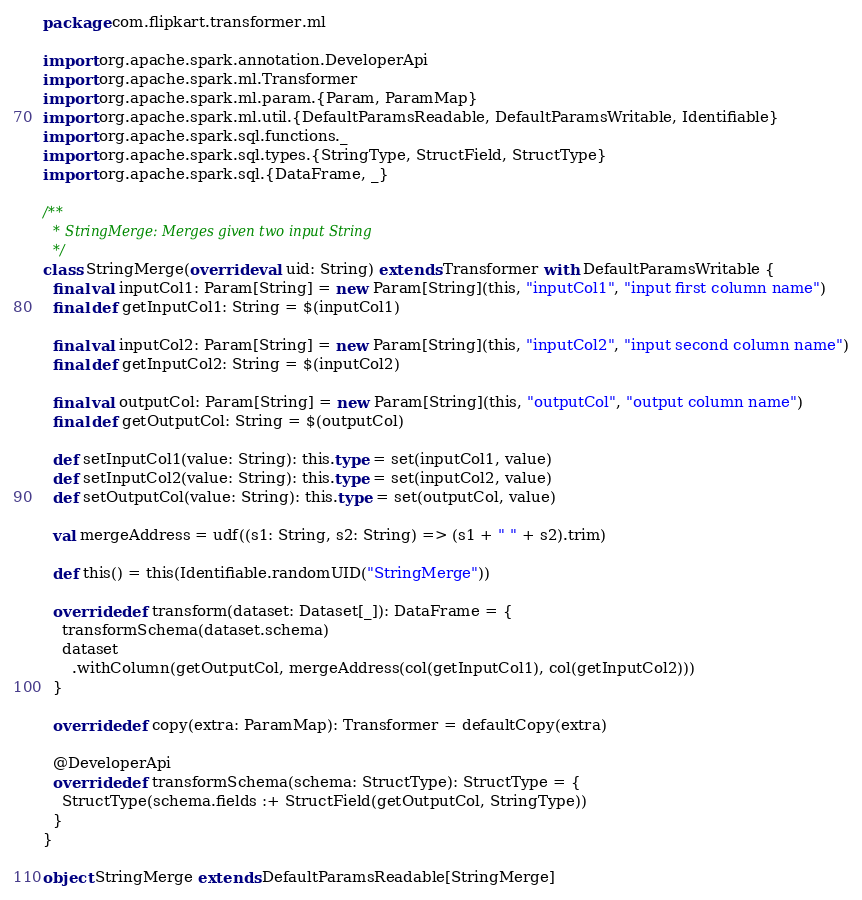Convert code to text. <code><loc_0><loc_0><loc_500><loc_500><_Scala_>package com.flipkart.transformer.ml

import org.apache.spark.annotation.DeveloperApi
import org.apache.spark.ml.Transformer
import org.apache.spark.ml.param.{Param, ParamMap}
import org.apache.spark.ml.util.{DefaultParamsReadable, DefaultParamsWritable, Identifiable}
import org.apache.spark.sql.functions._
import org.apache.spark.sql.types.{StringType, StructField, StructType}
import org.apache.spark.sql.{DataFrame, _}

/**
  * StringMerge: Merges given two input String
  */
class StringMerge(override val uid: String) extends Transformer with DefaultParamsWritable {
  final val inputCol1: Param[String] = new Param[String](this, "inputCol1", "input first column name")
  final def getInputCol1: String = $(inputCol1)

  final val inputCol2: Param[String] = new Param[String](this, "inputCol2", "input second column name")
  final def getInputCol2: String = $(inputCol2)

  final val outputCol: Param[String] = new Param[String](this, "outputCol", "output column name")
  final def getOutputCol: String = $(outputCol)

  def setInputCol1(value: String): this.type = set(inputCol1, value)
  def setInputCol2(value: String): this.type = set(inputCol2, value)
  def setOutputCol(value: String): this.type = set(outputCol, value)

  val mergeAddress = udf((s1: String, s2: String) => (s1 + " " + s2).trim)

  def this() = this(Identifiable.randomUID("StringMerge"))

  override def transform(dataset: Dataset[_]): DataFrame = {
    transformSchema(dataset.schema)
    dataset
      .withColumn(getOutputCol, mergeAddress(col(getInputCol1), col(getInputCol2)))
  }

  override def copy(extra: ParamMap): Transformer = defaultCopy(extra)

  @DeveloperApi
  override def transformSchema(schema: StructType): StructType = {
    StructType(schema.fields :+ StructField(getOutputCol, StringType))
  }
}

object StringMerge extends DefaultParamsReadable[StringMerge]
</code> 